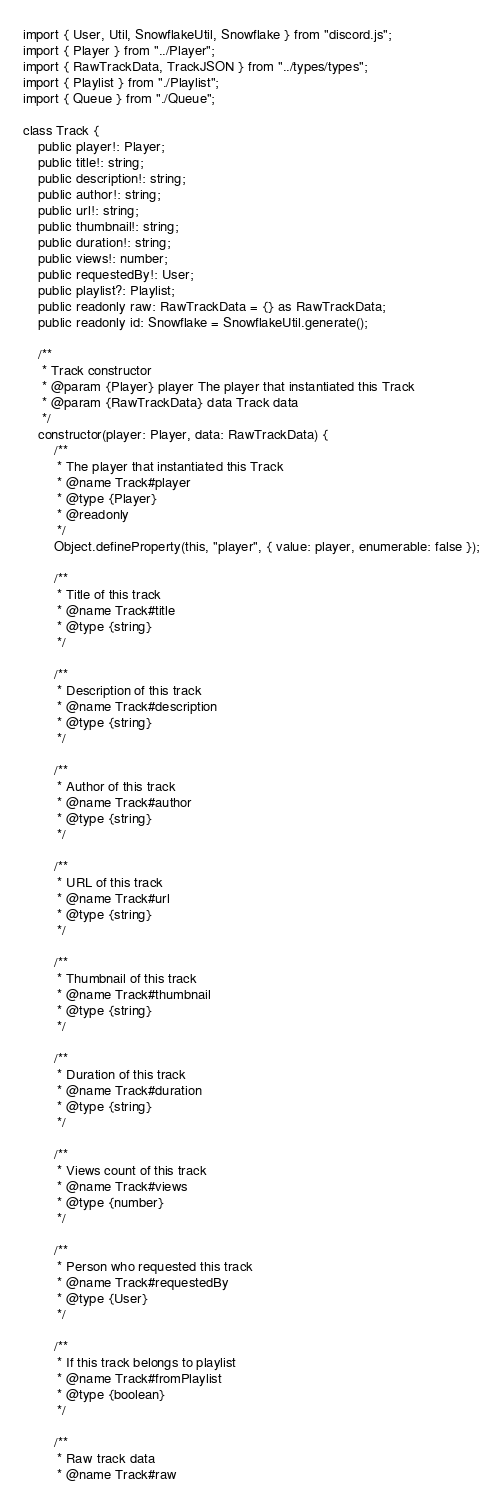<code> <loc_0><loc_0><loc_500><loc_500><_TypeScript_>import { User, Util, SnowflakeUtil, Snowflake } from "discord.js";
import { Player } from "../Player";
import { RawTrackData, TrackJSON } from "../types/types";
import { Playlist } from "./Playlist";
import { Queue } from "./Queue";

class Track {
    public player!: Player;
    public title!: string;
    public description!: string;
    public author!: string;
    public url!: string;
    public thumbnail!: string;
    public duration!: string;
    public views!: number;
    public requestedBy!: User;
    public playlist?: Playlist;
    public readonly raw: RawTrackData = {} as RawTrackData;
    public readonly id: Snowflake = SnowflakeUtil.generate();

    /**
     * Track constructor
     * @param {Player} player The player that instantiated this Track
     * @param {RawTrackData} data Track data
     */
    constructor(player: Player, data: RawTrackData) {
        /**
         * The player that instantiated this Track
         * @name Track#player
         * @type {Player}
         * @readonly
         */
        Object.defineProperty(this, "player", { value: player, enumerable: false });

        /**
         * Title of this track
         * @name Track#title
         * @type {string}
         */

        /**
         * Description of this track
         * @name Track#description
         * @type {string}
         */

        /**
         * Author of this track
         * @name Track#author
         * @type {string}
         */

        /**
         * URL of this track
         * @name Track#url
         * @type {string}
         */

        /**
         * Thumbnail of this track
         * @name Track#thumbnail
         * @type {string}
         */

        /**
         * Duration of this track
         * @name Track#duration
         * @type {string}
         */

        /**
         * Views count of this track
         * @name Track#views
         * @type {number}
         */

        /**
         * Person who requested this track
         * @name Track#requestedBy
         * @type {User}
         */

        /**
         * If this track belongs to playlist
         * @name Track#fromPlaylist
         * @type {boolean}
         */

        /**
         * Raw track data
         * @name Track#raw</code> 